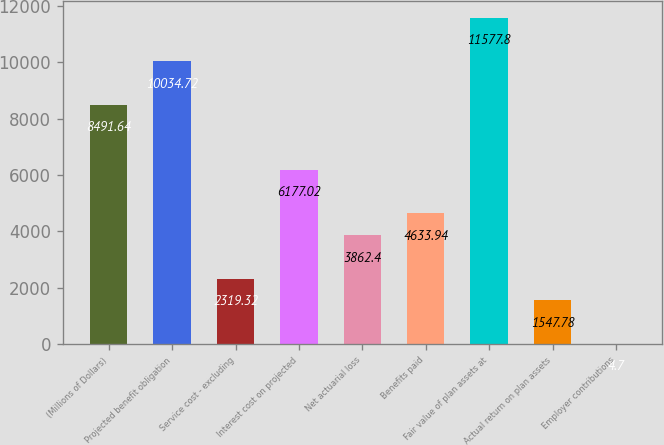Convert chart. <chart><loc_0><loc_0><loc_500><loc_500><bar_chart><fcel>(Millions of Dollars)<fcel>Projected benefit obligation<fcel>Service cost - excluding<fcel>Interest cost on projected<fcel>Net actuarial loss<fcel>Benefits paid<fcel>Fair value of plan assets at<fcel>Actual return on plan assets<fcel>Employer contributions<nl><fcel>8491.64<fcel>10034.7<fcel>2319.32<fcel>6177.02<fcel>3862.4<fcel>4633.94<fcel>11577.8<fcel>1547.78<fcel>4.7<nl></chart> 